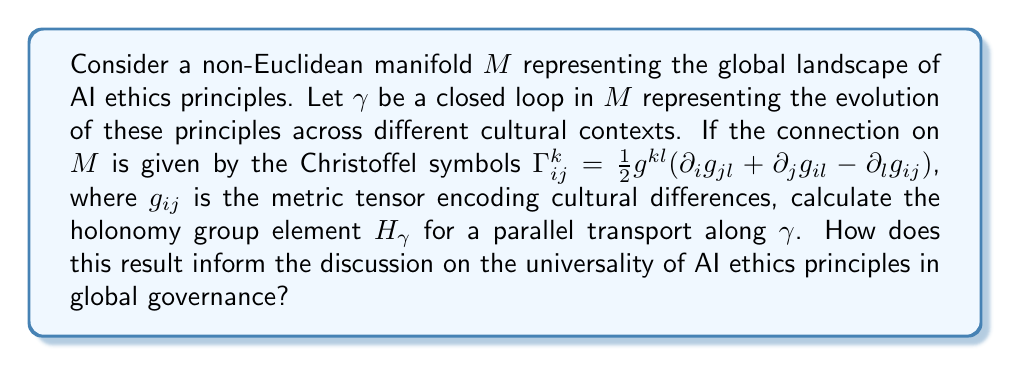What is the answer to this math problem? To solve this problem, we need to follow these steps:

1) First, we need to understand that the holonomy group element $H_\gamma$ represents how a vector changes when parallel transported along the closed loop $\gamma$. In the context of AI ethics, this change represents how ethical principles transform as they're interpreted across different cultures.

2) The parallel transport is governed by the connection, given by the Christoffel symbols $\Gamma_{ij}^k$. These symbols depend on the metric tensor $g_{ij}$, which encodes the "cultural distance" in our AI ethics landscape.

3) To calculate $H_\gamma$, we need to solve the parallel transport equation:

   $$\frac{D V^i}{dt} = \frac{dV^i}{dt} + \Gamma_{jk}^i V^j \frac{dx^k}{dt} = 0$$

   where $V^i$ is a vector being transported and $\frac{dx^k}{dt}$ is the tangent vector to $\gamma$.

4) The solution to this equation gives us the holonomy group element:

   $$H_\gamma = \mathcal{P} \exp\left(-\oint_\gamma \Gamma_{jk}^i dx^k\right)$$

   where $\mathcal{P}$ denotes path-ordering.

5) The exact calculation depends on the specific form of $g_{ij}$ and the path $\gamma$, which would need to be defined based on empirical data about cultural differences in AI ethics.

6) If $H_\gamma$ is close to the identity, it suggests that AI ethics principles remain relatively consistent across cultural contexts. If $H_\gamma$ deviates significantly from the identity, it indicates that these principles undergo substantial transformation.

7) The eigenvalues and eigenvectors of $H_\gamma$ can provide insight into which aspects of AI ethics are most affected by cultural differences.

8) This mathematical framework allows for a quantitative discussion of the universality of AI ethics principles. If the holonomy group is small (i.e., $H_\gamma$ is close to the identity for most loops), it suggests a high degree of universality. A large holonomy group suggests significant cultural dependence.
Answer: $H_\gamma = \mathcal{P} \exp\left(-\oint_\gamma \Gamma_{jk}^i dx^k\right)$, with eigenvalues and eigenvectors indicating universality of AI ethics principles. 